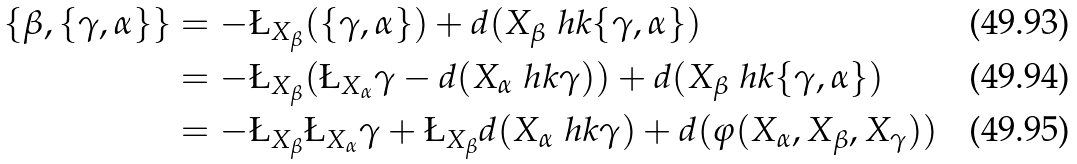<formula> <loc_0><loc_0><loc_500><loc_500>\{ \beta , \{ \gamma , \alpha \} \} & = - \L _ { X _ { \beta } } ( \{ \gamma , \alpha \} ) + d ( X _ { \beta } \ h k \{ \gamma , \alpha \} ) \\ & = - \L _ { X _ { \beta } } ( \L _ { X _ { \alpha } } \gamma - d ( X _ { \alpha } \ h k \gamma ) ) + d ( X _ { \beta } \ h k \{ \gamma , \alpha \} ) \\ & = - \L _ { X _ { \beta } } \L _ { X _ { \alpha } } \gamma + \L _ { X _ { \beta } } d ( X _ { \alpha } \ h k \gamma ) + d ( \varphi ( X _ { \alpha } , X _ { \beta } , X _ { \gamma } ) )</formula> 